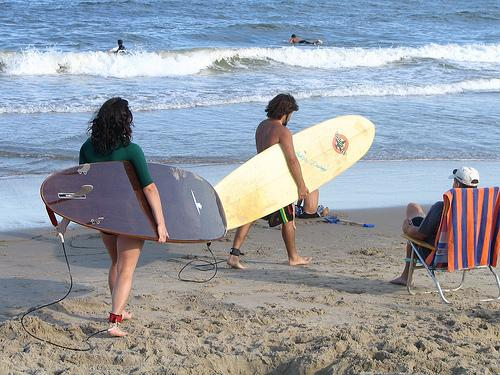Question: what are these people about to do?
Choices:
A. Surf.
B. Swim.
C. Play beach basketball.
D. Sun tan.
Answer with the letter. Answer: A Question: what is the weather like?
Choices:
A. Clear.
B. Warm.
C. Sunny.
D. Cloudy.
Answer with the letter. Answer: A Question: who is hold the surfboards?
Choices:
A. The men.
B. The surfers.
C. Teenagers.
D. The girls.
Answer with the letter. Answer: B Question: where is this photo taken?
Choices:
A. At the beach.
B. Oceanside.
C. At a lake.
D. At a river.
Answer with the letter. Answer: A Question: how many surf boards are there?
Choices:
A. One.
B. Two.
C. Three.
D. Four.
Answer with the letter. Answer: B 